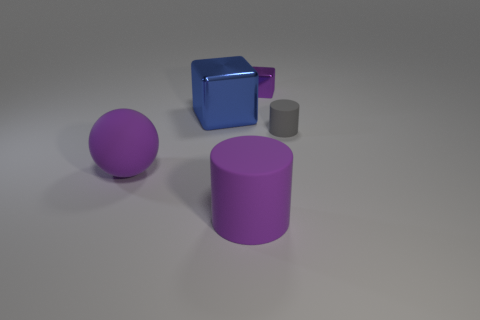Add 3 small purple metal things. How many objects exist? 8 Subtract all cylinders. How many objects are left? 3 Add 1 big cyan metallic cubes. How many big cyan metallic cubes exist? 1 Subtract 0 cyan spheres. How many objects are left? 5 Subtract all cyan blocks. Subtract all cylinders. How many objects are left? 3 Add 4 metallic objects. How many metallic objects are left? 6 